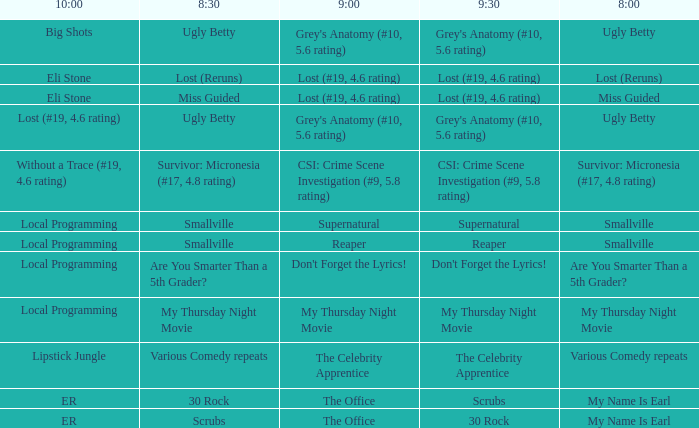What is at 10:00 when at 9:00 it is lost (#19, 4.6 rating) and at 8:30 it is lost (reruns)? Eli Stone. 